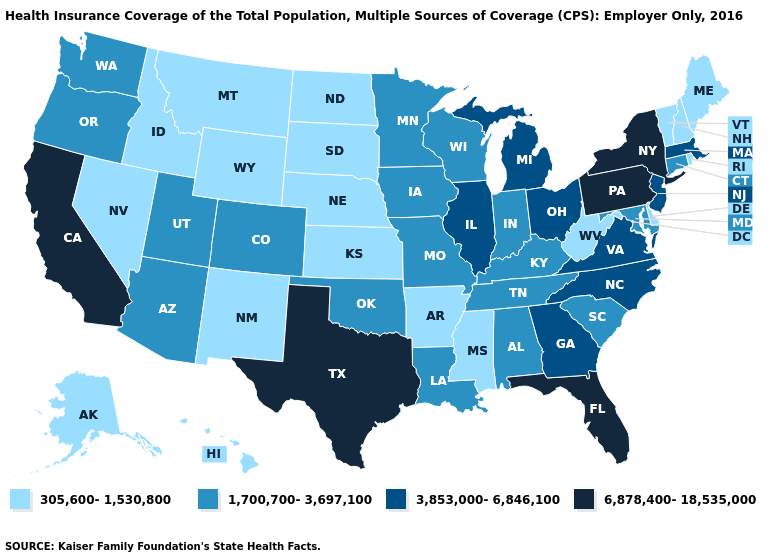What is the value of Idaho?
Be succinct. 305,600-1,530,800. Does Iowa have a higher value than Michigan?
Answer briefly. No. What is the value of Iowa?
Give a very brief answer. 1,700,700-3,697,100. Among the states that border Idaho , does Nevada have the lowest value?
Short answer required. Yes. Name the states that have a value in the range 6,878,400-18,535,000?
Give a very brief answer. California, Florida, New York, Pennsylvania, Texas. Which states have the lowest value in the USA?
Be succinct. Alaska, Arkansas, Delaware, Hawaii, Idaho, Kansas, Maine, Mississippi, Montana, Nebraska, Nevada, New Hampshire, New Mexico, North Dakota, Rhode Island, South Dakota, Vermont, West Virginia, Wyoming. What is the value of Nevada?
Write a very short answer. 305,600-1,530,800. Is the legend a continuous bar?
Answer briefly. No. What is the value of Pennsylvania?
Concise answer only. 6,878,400-18,535,000. Among the states that border Arizona , which have the highest value?
Short answer required. California. What is the value of Virginia?
Concise answer only. 3,853,000-6,846,100. What is the value of South Carolina?
Short answer required. 1,700,700-3,697,100. Does the first symbol in the legend represent the smallest category?
Quick response, please. Yes. Among the states that border Massachusetts , does New Hampshire have the highest value?
Short answer required. No. Name the states that have a value in the range 6,878,400-18,535,000?
Be succinct. California, Florida, New York, Pennsylvania, Texas. 